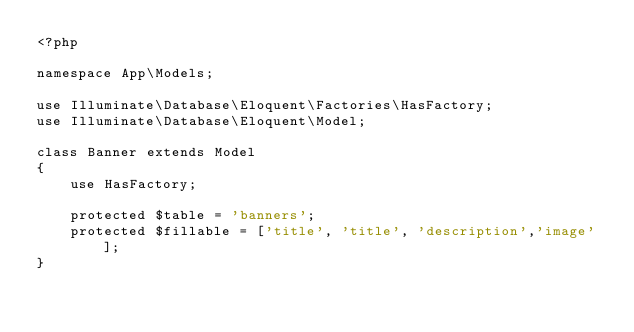Convert code to text. <code><loc_0><loc_0><loc_500><loc_500><_PHP_><?php

namespace App\Models;

use Illuminate\Database\Eloquent\Factories\HasFactory;
use Illuminate\Database\Eloquent\Model;

class Banner extends Model
{
    use HasFactory;
    
    protected $table = 'banners';
    protected $fillable = ['title', 'title', 'description','image'];
}</code> 